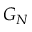<formula> <loc_0><loc_0><loc_500><loc_500>G _ { N }</formula> 